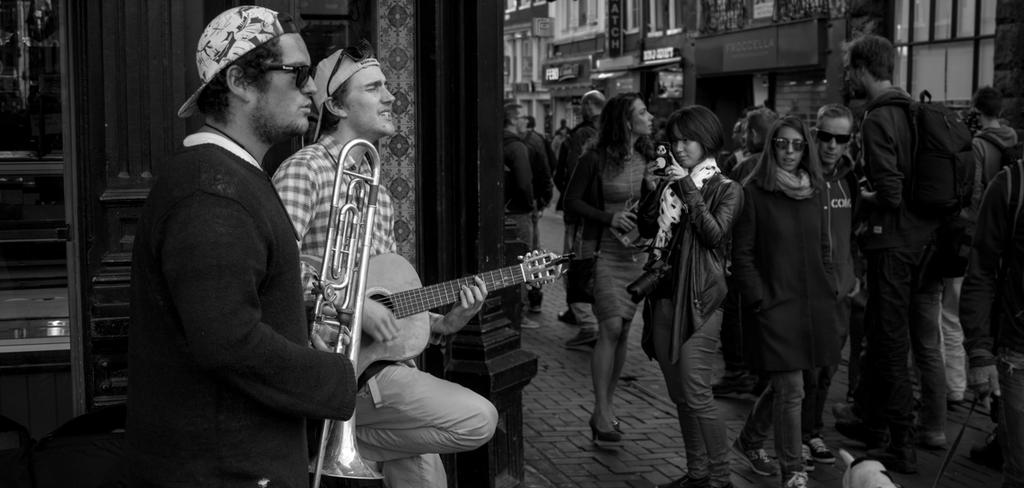What are the people in the image doing? People are walking on the streets, and some of them are playing musical instruments. What can be seen in the background of the image? There are buildings in the background. What type of bean is being used as a guitar pick in the image? There is no bean or guitar present in the image, so it is not possible to determine if a bean is being used as a guitar pick. 